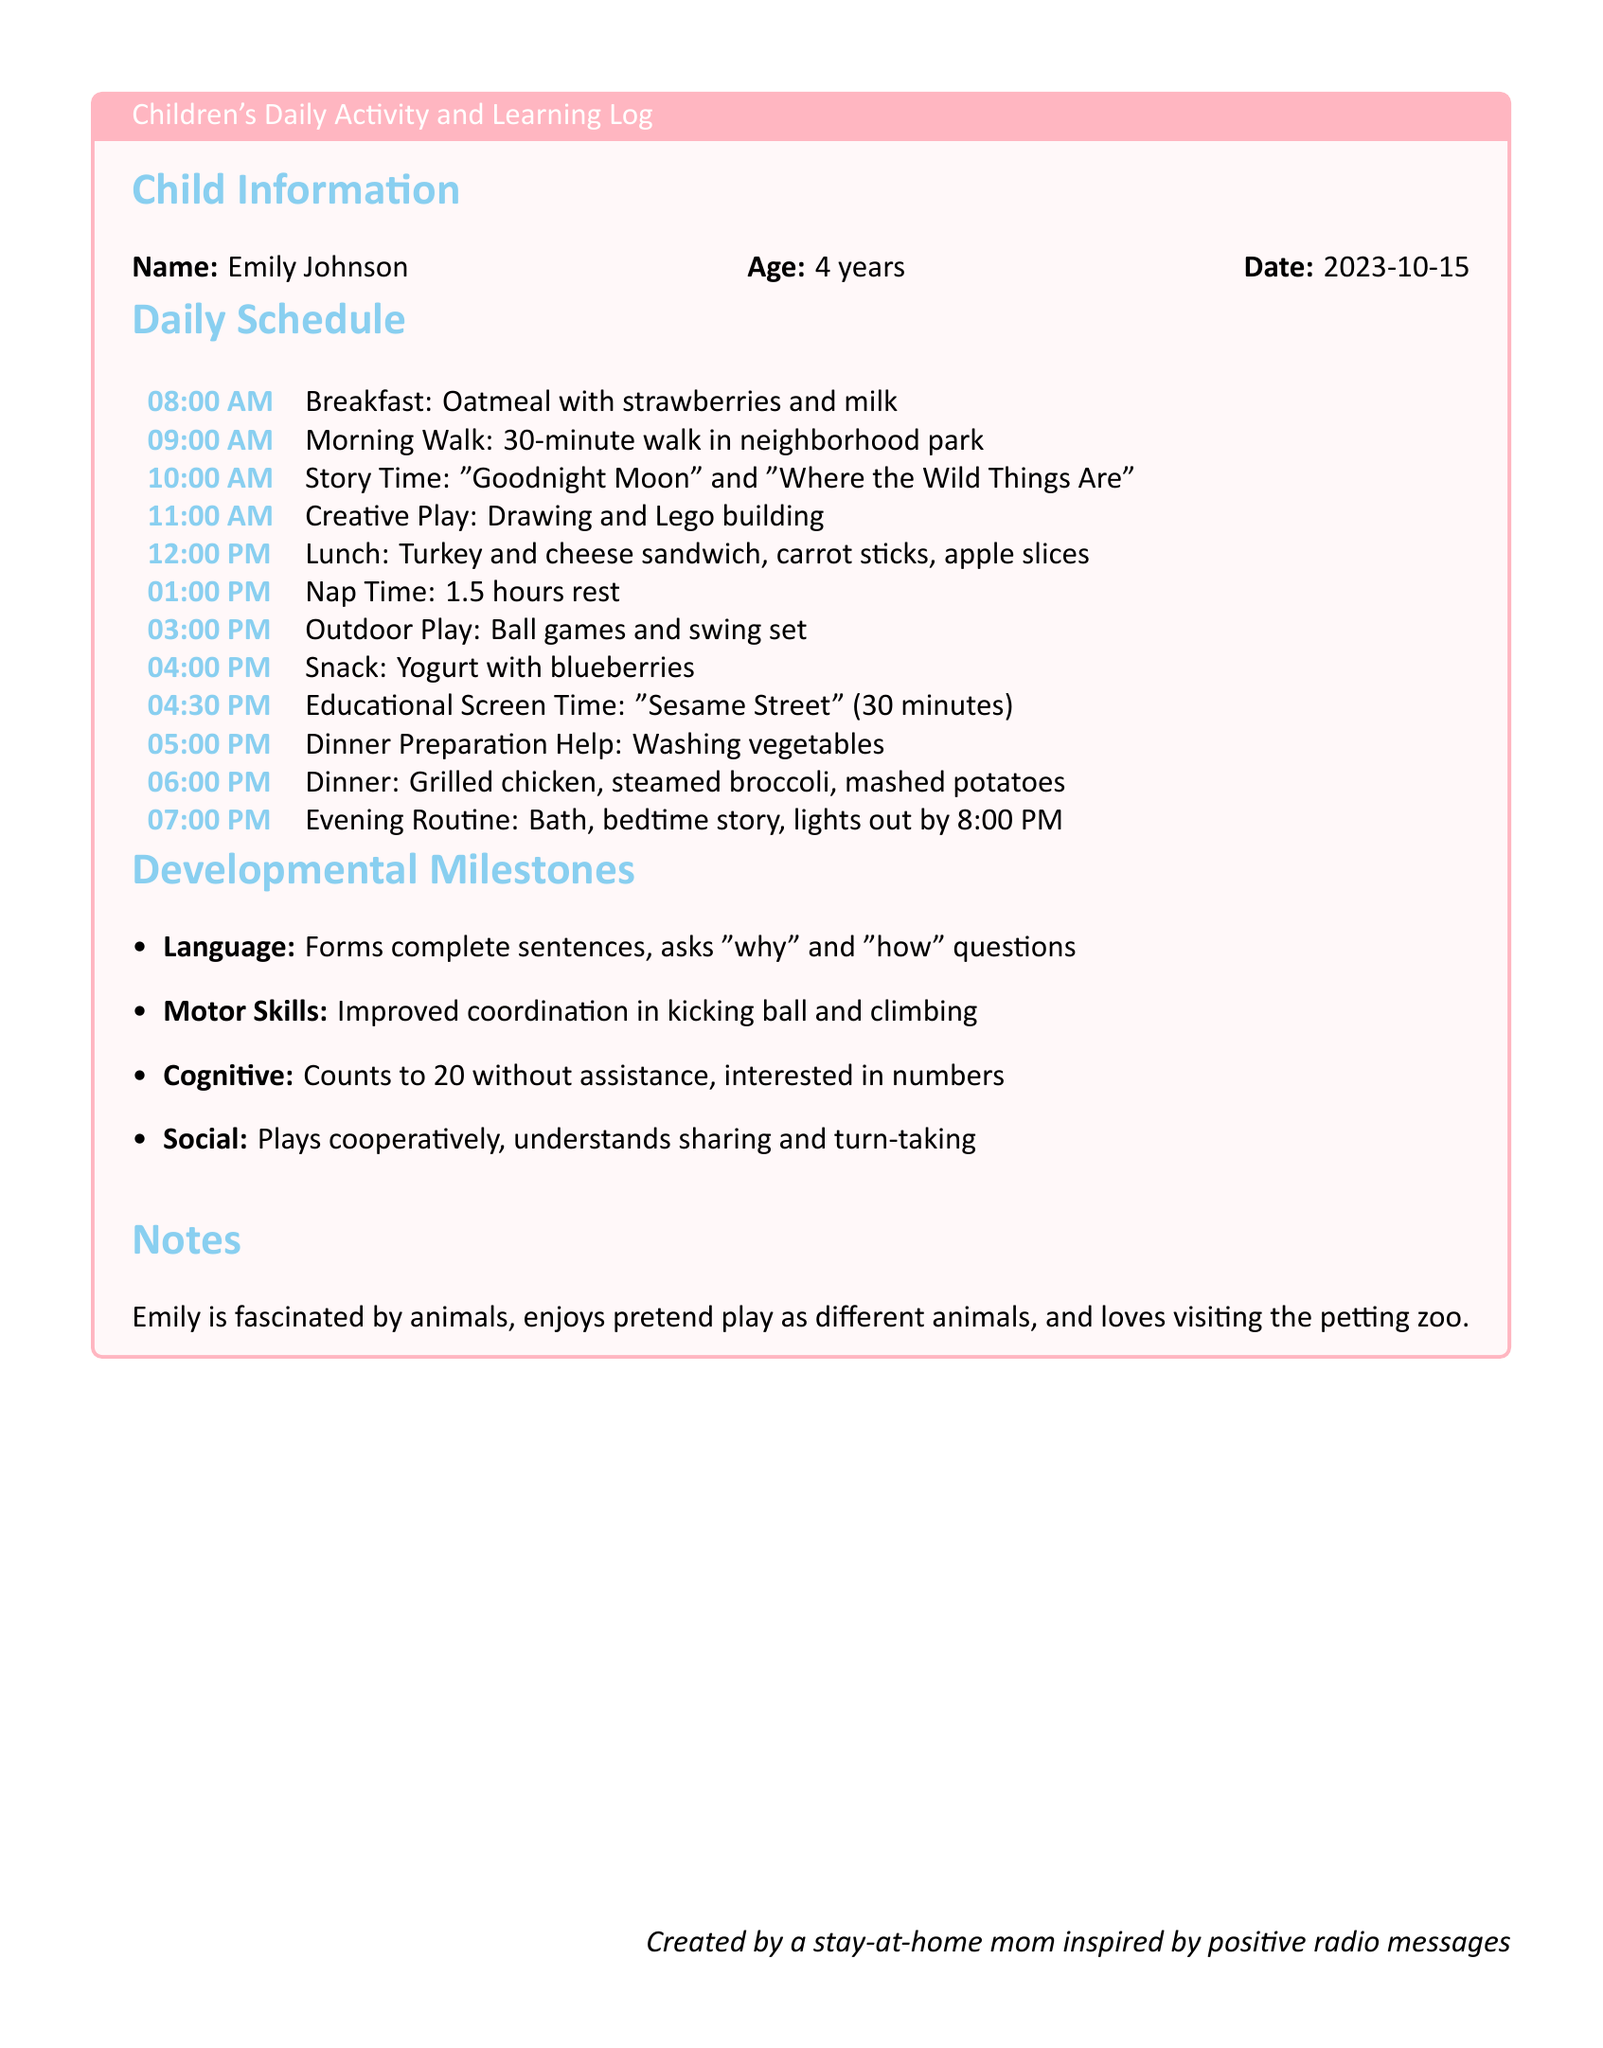What is Emily's age? Emily's age is stated in the child's information section of the document.
Answer: 4 years What time does Emily have lunch? The document specifies the time for lunch in the daily schedule.
Answer: 12:00 PM What is the first story listed during story time? The first story mentioned in the story time section of the daily schedule is the first title listed.
Answer: "Goodnight Moon" What developmental milestone relates to language? The developmental milestones section lists a specific milestone for language.
Answer: Forms complete sentences How long is Emily's nap time? The document specifies the duration of nap time in the daily schedule.
Answer: 1.5 hours What activity does Emily do at 4 PM? The daily schedule indicates the activity at 4 PM.
Answer: Snack Which animal-related activity does Emily enjoy? The notes mention an activity related to animals that Emily enjoys.
Answer: Pretend play as different animals What meal does Emily help prepare? The daily schedule indicates Emily's involvement in meal preparation.
Answer: Dinner Preparation Help What does Emily count to without assistance? The milestone describes the cognitive skill relating to counting.
Answer: Counts to 20 